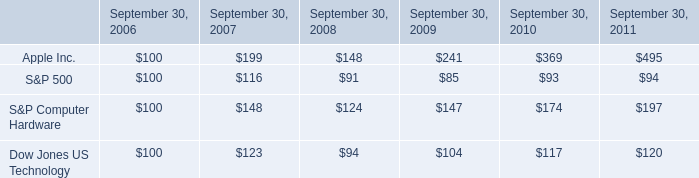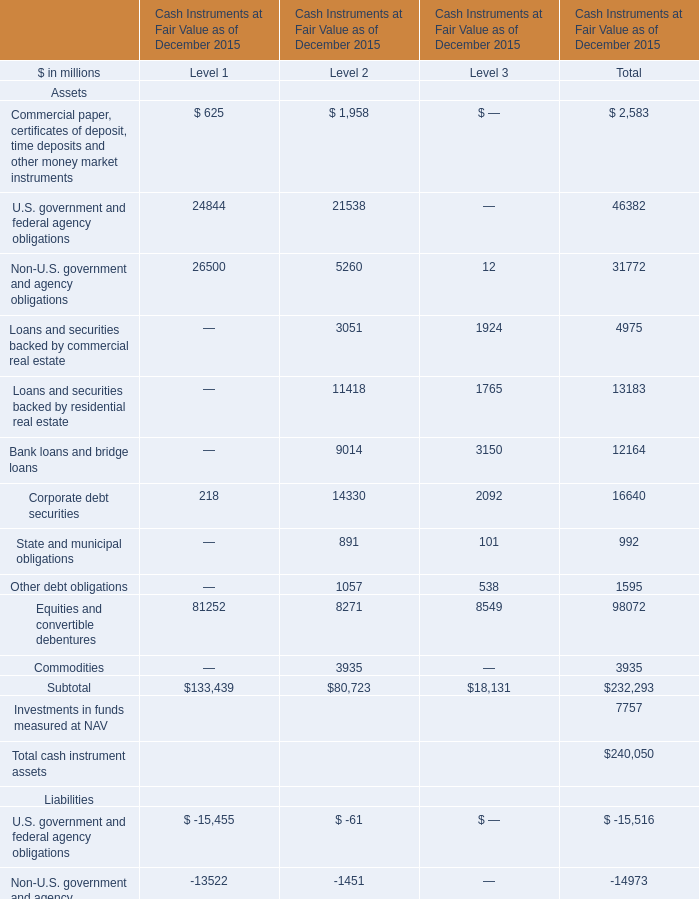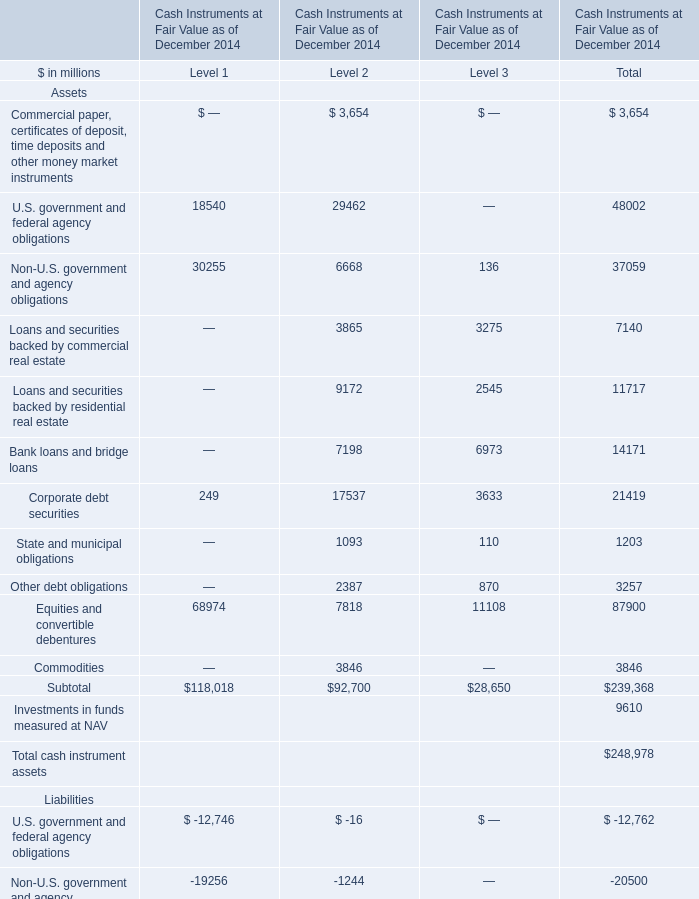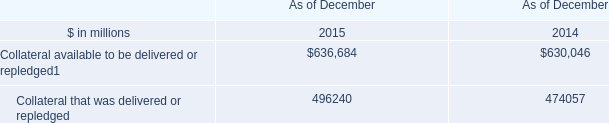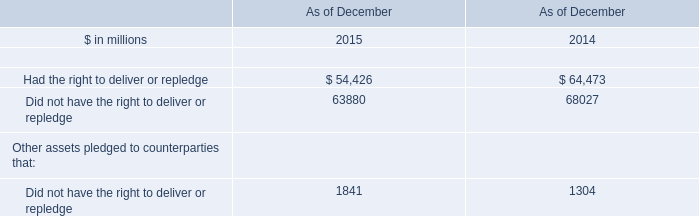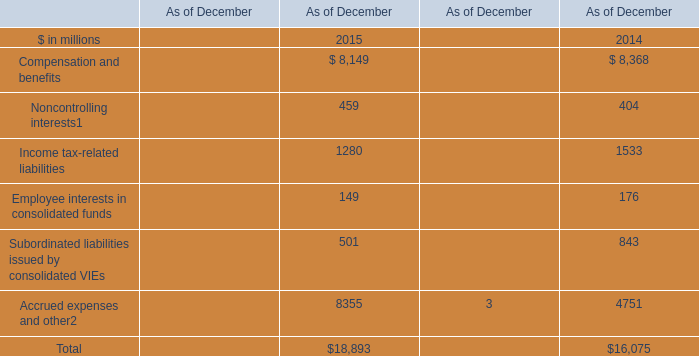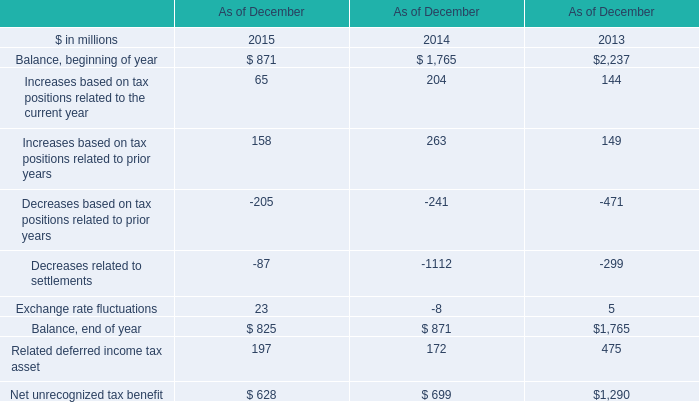Does the value of Corporate debt securities of Assets for Level 1 greater than that for Level 2 ? 
Answer: No. 